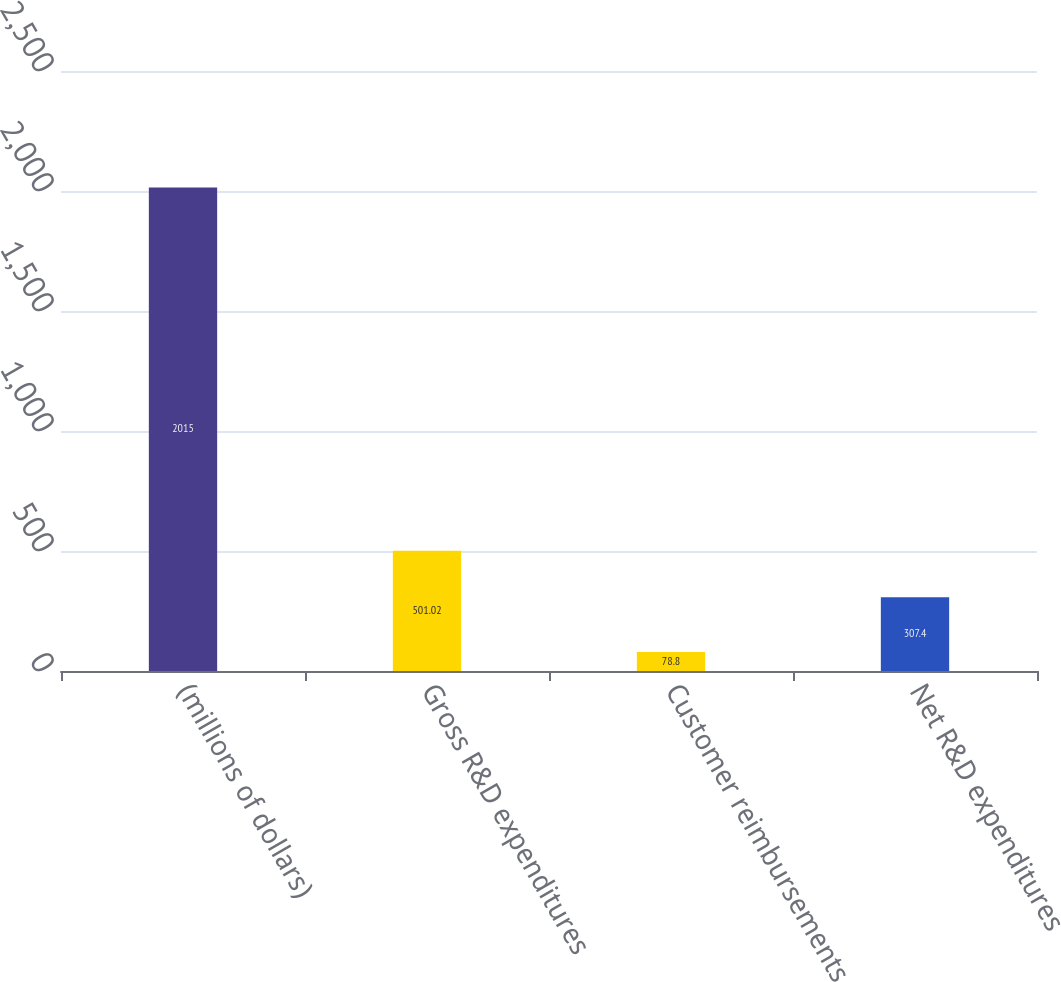<chart> <loc_0><loc_0><loc_500><loc_500><bar_chart><fcel>(millions of dollars)<fcel>Gross R&D expenditures<fcel>Customer reimbursements<fcel>Net R&D expenditures<nl><fcel>2015<fcel>501.02<fcel>78.8<fcel>307.4<nl></chart> 